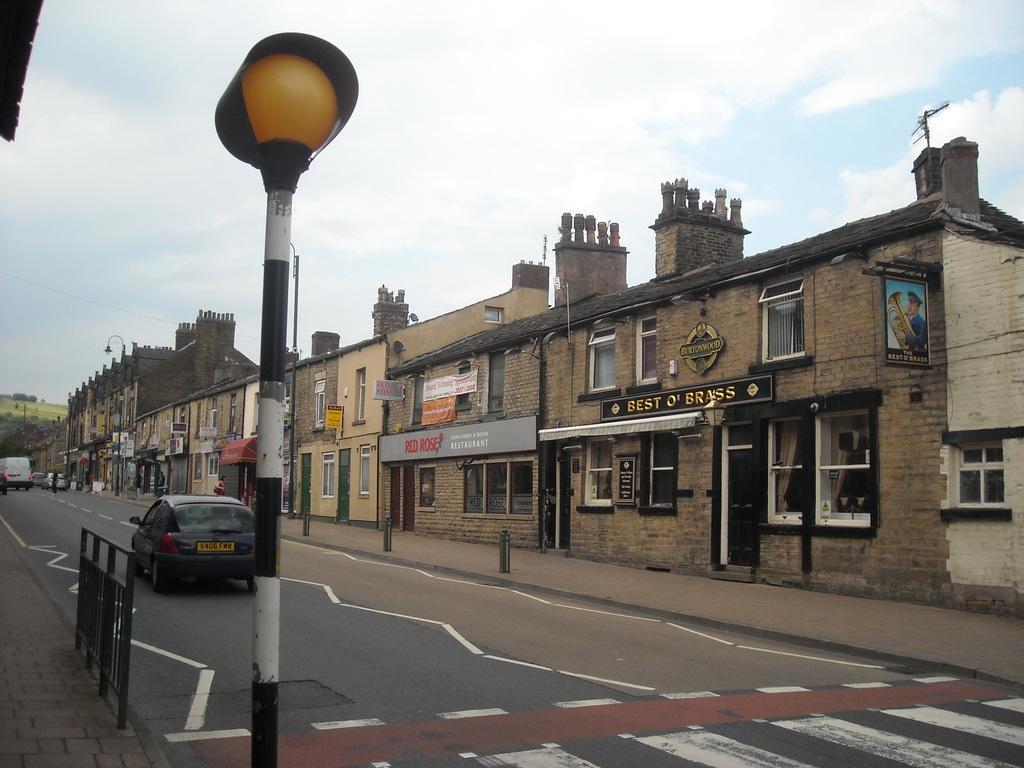Describe this image in one or two sentences. In this picture there are vehicles on the road. There are buildings and there are boards on the buildings and there are trees. In the foreground there is a pole and there is a railing on the footpath. At the top there is sky and there are clouds. At the bottom there is a road. 